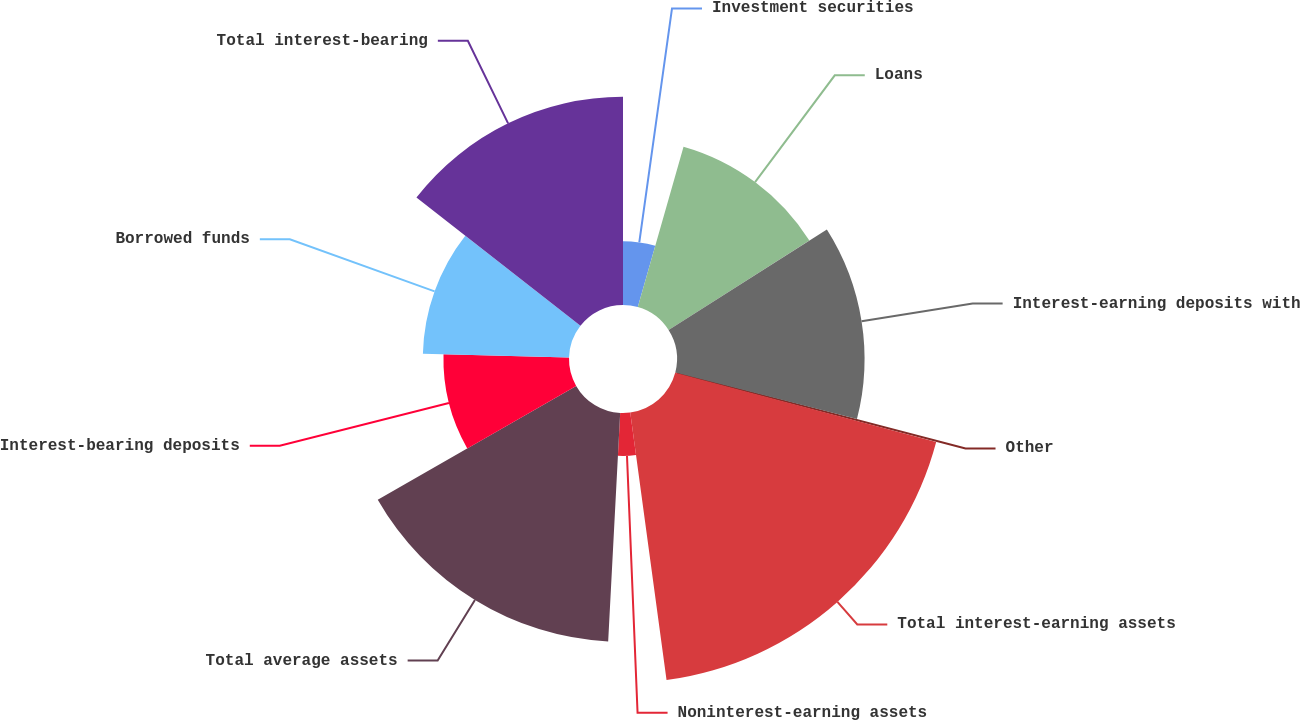Convert chart to OTSL. <chart><loc_0><loc_0><loc_500><loc_500><pie_chart><fcel>Investment securities<fcel>Loans<fcel>Interest-earning deposits with<fcel>Other<fcel>Total interest-earning assets<fcel>Noninterest-earning assets<fcel>Total average assets<fcel>Interest-bearing deposits<fcel>Borrowed funds<fcel>Total interest-bearing<nl><fcel>4.42%<fcel>11.57%<fcel>13.01%<fcel>0.12%<fcel>18.73%<fcel>2.98%<fcel>15.87%<fcel>8.71%<fcel>10.14%<fcel>14.44%<nl></chart> 